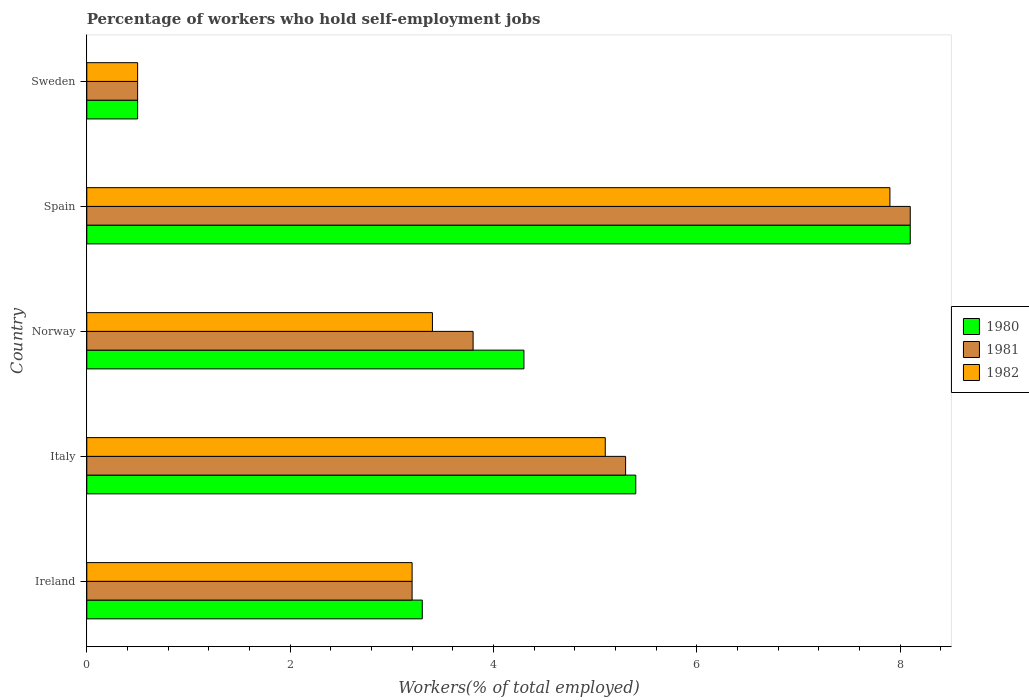How many different coloured bars are there?
Offer a very short reply. 3. How many groups of bars are there?
Provide a succinct answer. 5. Are the number of bars per tick equal to the number of legend labels?
Offer a very short reply. Yes. What is the label of the 5th group of bars from the top?
Offer a very short reply. Ireland. What is the percentage of self-employed workers in 1981 in Norway?
Make the answer very short. 3.8. Across all countries, what is the maximum percentage of self-employed workers in 1982?
Your answer should be compact. 7.9. Across all countries, what is the minimum percentage of self-employed workers in 1981?
Make the answer very short. 0.5. In which country was the percentage of self-employed workers in 1980 minimum?
Provide a succinct answer. Sweden. What is the total percentage of self-employed workers in 1982 in the graph?
Your answer should be very brief. 20.1. What is the difference between the percentage of self-employed workers in 1980 in Norway and that in Sweden?
Make the answer very short. 3.8. What is the difference between the percentage of self-employed workers in 1981 in Italy and the percentage of self-employed workers in 1982 in Spain?
Offer a terse response. -2.6. What is the average percentage of self-employed workers in 1982 per country?
Make the answer very short. 4.02. What is the difference between the percentage of self-employed workers in 1980 and percentage of self-employed workers in 1982 in Italy?
Provide a short and direct response. 0.3. What is the ratio of the percentage of self-employed workers in 1980 in Norway to that in Spain?
Give a very brief answer. 0.53. Is the percentage of self-employed workers in 1981 in Ireland less than that in Norway?
Keep it short and to the point. Yes. Is the difference between the percentage of self-employed workers in 1980 in Ireland and Sweden greater than the difference between the percentage of self-employed workers in 1982 in Ireland and Sweden?
Ensure brevity in your answer.  Yes. What is the difference between the highest and the second highest percentage of self-employed workers in 1981?
Keep it short and to the point. 2.8. What is the difference between the highest and the lowest percentage of self-employed workers in 1981?
Keep it short and to the point. 7.6. In how many countries, is the percentage of self-employed workers in 1982 greater than the average percentage of self-employed workers in 1982 taken over all countries?
Keep it short and to the point. 2. What does the 3rd bar from the top in Sweden represents?
Keep it short and to the point. 1980. How many countries are there in the graph?
Make the answer very short. 5. Are the values on the major ticks of X-axis written in scientific E-notation?
Offer a very short reply. No. Where does the legend appear in the graph?
Your response must be concise. Center right. How many legend labels are there?
Ensure brevity in your answer.  3. What is the title of the graph?
Make the answer very short. Percentage of workers who hold self-employment jobs. Does "1987" appear as one of the legend labels in the graph?
Provide a short and direct response. No. What is the label or title of the X-axis?
Offer a terse response. Workers(% of total employed). What is the label or title of the Y-axis?
Keep it short and to the point. Country. What is the Workers(% of total employed) of 1980 in Ireland?
Keep it short and to the point. 3.3. What is the Workers(% of total employed) in 1981 in Ireland?
Your response must be concise. 3.2. What is the Workers(% of total employed) of 1982 in Ireland?
Your answer should be compact. 3.2. What is the Workers(% of total employed) in 1980 in Italy?
Offer a very short reply. 5.4. What is the Workers(% of total employed) of 1981 in Italy?
Make the answer very short. 5.3. What is the Workers(% of total employed) of 1982 in Italy?
Provide a succinct answer. 5.1. What is the Workers(% of total employed) of 1980 in Norway?
Your response must be concise. 4.3. What is the Workers(% of total employed) of 1981 in Norway?
Keep it short and to the point. 3.8. What is the Workers(% of total employed) in 1982 in Norway?
Your response must be concise. 3.4. What is the Workers(% of total employed) of 1980 in Spain?
Ensure brevity in your answer.  8.1. What is the Workers(% of total employed) in 1981 in Spain?
Keep it short and to the point. 8.1. What is the Workers(% of total employed) in 1982 in Spain?
Give a very brief answer. 7.9. What is the Workers(% of total employed) of 1982 in Sweden?
Provide a short and direct response. 0.5. Across all countries, what is the maximum Workers(% of total employed) in 1980?
Your answer should be very brief. 8.1. Across all countries, what is the maximum Workers(% of total employed) of 1981?
Give a very brief answer. 8.1. Across all countries, what is the maximum Workers(% of total employed) in 1982?
Give a very brief answer. 7.9. Across all countries, what is the minimum Workers(% of total employed) of 1981?
Your answer should be very brief. 0.5. What is the total Workers(% of total employed) in 1980 in the graph?
Ensure brevity in your answer.  21.6. What is the total Workers(% of total employed) in 1981 in the graph?
Give a very brief answer. 20.9. What is the total Workers(% of total employed) in 1982 in the graph?
Your answer should be compact. 20.1. What is the difference between the Workers(% of total employed) of 1980 in Ireland and that in Italy?
Your answer should be very brief. -2.1. What is the difference between the Workers(% of total employed) in 1981 in Ireland and that in Italy?
Your answer should be very brief. -2.1. What is the difference between the Workers(% of total employed) of 1982 in Ireland and that in Italy?
Provide a short and direct response. -1.9. What is the difference between the Workers(% of total employed) in 1980 in Ireland and that in Norway?
Ensure brevity in your answer.  -1. What is the difference between the Workers(% of total employed) of 1981 in Ireland and that in Norway?
Give a very brief answer. -0.6. What is the difference between the Workers(% of total employed) of 1980 in Ireland and that in Spain?
Make the answer very short. -4.8. What is the difference between the Workers(% of total employed) of 1981 in Ireland and that in Spain?
Ensure brevity in your answer.  -4.9. What is the difference between the Workers(% of total employed) in 1980 in Ireland and that in Sweden?
Provide a short and direct response. 2.8. What is the difference between the Workers(% of total employed) in 1981 in Ireland and that in Sweden?
Provide a short and direct response. 2.7. What is the difference between the Workers(% of total employed) of 1980 in Italy and that in Norway?
Offer a very short reply. 1.1. What is the difference between the Workers(% of total employed) in 1981 in Italy and that in Norway?
Your response must be concise. 1.5. What is the difference between the Workers(% of total employed) in 1980 in Italy and that in Spain?
Offer a very short reply. -2.7. What is the difference between the Workers(% of total employed) of 1981 in Italy and that in Spain?
Give a very brief answer. -2.8. What is the difference between the Workers(% of total employed) in 1982 in Italy and that in Spain?
Your answer should be very brief. -2.8. What is the difference between the Workers(% of total employed) in 1981 in Italy and that in Sweden?
Offer a very short reply. 4.8. What is the difference between the Workers(% of total employed) of 1982 in Italy and that in Sweden?
Keep it short and to the point. 4.6. What is the difference between the Workers(% of total employed) of 1980 in Norway and that in Spain?
Give a very brief answer. -3.8. What is the difference between the Workers(% of total employed) in 1982 in Norway and that in Spain?
Offer a very short reply. -4.5. What is the difference between the Workers(% of total employed) of 1980 in Spain and that in Sweden?
Make the answer very short. 7.6. What is the difference between the Workers(% of total employed) in 1981 in Spain and that in Sweden?
Provide a succinct answer. 7.6. What is the difference between the Workers(% of total employed) in 1980 in Ireland and the Workers(% of total employed) in 1982 in Italy?
Your answer should be compact. -1.8. What is the difference between the Workers(% of total employed) of 1981 in Ireland and the Workers(% of total employed) of 1982 in Italy?
Your answer should be compact. -1.9. What is the difference between the Workers(% of total employed) of 1980 in Ireland and the Workers(% of total employed) of 1981 in Norway?
Offer a terse response. -0.5. What is the difference between the Workers(% of total employed) of 1980 in Ireland and the Workers(% of total employed) of 1982 in Norway?
Keep it short and to the point. -0.1. What is the difference between the Workers(% of total employed) of 1981 in Ireland and the Workers(% of total employed) of 1982 in Norway?
Make the answer very short. -0.2. What is the difference between the Workers(% of total employed) of 1980 in Ireland and the Workers(% of total employed) of 1981 in Spain?
Make the answer very short. -4.8. What is the difference between the Workers(% of total employed) of 1980 in Ireland and the Workers(% of total employed) of 1982 in Spain?
Keep it short and to the point. -4.6. What is the difference between the Workers(% of total employed) in 1980 in Italy and the Workers(% of total employed) in 1981 in Norway?
Keep it short and to the point. 1.6. What is the difference between the Workers(% of total employed) of 1981 in Italy and the Workers(% of total employed) of 1982 in Norway?
Ensure brevity in your answer.  1.9. What is the difference between the Workers(% of total employed) of 1980 in Italy and the Workers(% of total employed) of 1982 in Spain?
Provide a succinct answer. -2.5. What is the difference between the Workers(% of total employed) in 1980 in Italy and the Workers(% of total employed) in 1981 in Sweden?
Ensure brevity in your answer.  4.9. What is the difference between the Workers(% of total employed) in 1980 in Norway and the Workers(% of total employed) in 1982 in Spain?
Your response must be concise. -3.6. What is the difference between the Workers(% of total employed) of 1980 in Norway and the Workers(% of total employed) of 1981 in Sweden?
Provide a succinct answer. 3.8. What is the difference between the Workers(% of total employed) in 1981 in Norway and the Workers(% of total employed) in 1982 in Sweden?
Your answer should be very brief. 3.3. What is the difference between the Workers(% of total employed) of 1981 in Spain and the Workers(% of total employed) of 1982 in Sweden?
Your response must be concise. 7.6. What is the average Workers(% of total employed) in 1980 per country?
Keep it short and to the point. 4.32. What is the average Workers(% of total employed) of 1981 per country?
Give a very brief answer. 4.18. What is the average Workers(% of total employed) of 1982 per country?
Provide a succinct answer. 4.02. What is the difference between the Workers(% of total employed) in 1980 and Workers(% of total employed) in 1982 in Ireland?
Your response must be concise. 0.1. What is the difference between the Workers(% of total employed) in 1981 and Workers(% of total employed) in 1982 in Norway?
Your answer should be compact. 0.4. What is the difference between the Workers(% of total employed) of 1980 and Workers(% of total employed) of 1981 in Spain?
Give a very brief answer. 0. What is the difference between the Workers(% of total employed) of 1980 and Workers(% of total employed) of 1982 in Spain?
Give a very brief answer. 0.2. What is the difference between the Workers(% of total employed) in 1981 and Workers(% of total employed) in 1982 in Spain?
Keep it short and to the point. 0.2. What is the difference between the Workers(% of total employed) in 1980 and Workers(% of total employed) in 1982 in Sweden?
Provide a succinct answer. 0. What is the difference between the Workers(% of total employed) of 1981 and Workers(% of total employed) of 1982 in Sweden?
Make the answer very short. 0. What is the ratio of the Workers(% of total employed) in 1980 in Ireland to that in Italy?
Your answer should be compact. 0.61. What is the ratio of the Workers(% of total employed) in 1981 in Ireland to that in Italy?
Ensure brevity in your answer.  0.6. What is the ratio of the Workers(% of total employed) in 1982 in Ireland to that in Italy?
Provide a short and direct response. 0.63. What is the ratio of the Workers(% of total employed) of 1980 in Ireland to that in Norway?
Offer a very short reply. 0.77. What is the ratio of the Workers(% of total employed) in 1981 in Ireland to that in Norway?
Ensure brevity in your answer.  0.84. What is the ratio of the Workers(% of total employed) of 1980 in Ireland to that in Spain?
Provide a short and direct response. 0.41. What is the ratio of the Workers(% of total employed) in 1981 in Ireland to that in Spain?
Make the answer very short. 0.4. What is the ratio of the Workers(% of total employed) of 1982 in Ireland to that in Spain?
Your answer should be very brief. 0.41. What is the ratio of the Workers(% of total employed) of 1980 in Ireland to that in Sweden?
Ensure brevity in your answer.  6.6. What is the ratio of the Workers(% of total employed) in 1981 in Ireland to that in Sweden?
Your response must be concise. 6.4. What is the ratio of the Workers(% of total employed) of 1982 in Ireland to that in Sweden?
Your answer should be very brief. 6.4. What is the ratio of the Workers(% of total employed) in 1980 in Italy to that in Norway?
Give a very brief answer. 1.26. What is the ratio of the Workers(% of total employed) of 1981 in Italy to that in Norway?
Make the answer very short. 1.39. What is the ratio of the Workers(% of total employed) of 1981 in Italy to that in Spain?
Keep it short and to the point. 0.65. What is the ratio of the Workers(% of total employed) in 1982 in Italy to that in Spain?
Offer a very short reply. 0.65. What is the ratio of the Workers(% of total employed) of 1981 in Italy to that in Sweden?
Offer a very short reply. 10.6. What is the ratio of the Workers(% of total employed) in 1982 in Italy to that in Sweden?
Offer a very short reply. 10.2. What is the ratio of the Workers(% of total employed) in 1980 in Norway to that in Spain?
Your answer should be very brief. 0.53. What is the ratio of the Workers(% of total employed) of 1981 in Norway to that in Spain?
Make the answer very short. 0.47. What is the ratio of the Workers(% of total employed) in 1982 in Norway to that in Spain?
Your response must be concise. 0.43. What is the ratio of the Workers(% of total employed) in 1980 in Norway to that in Sweden?
Offer a terse response. 8.6. What is the ratio of the Workers(% of total employed) of 1980 in Spain to that in Sweden?
Provide a short and direct response. 16.2. What is the difference between the highest and the second highest Workers(% of total employed) of 1980?
Provide a short and direct response. 2.7. What is the difference between the highest and the second highest Workers(% of total employed) in 1982?
Make the answer very short. 2.8. What is the difference between the highest and the lowest Workers(% of total employed) in 1981?
Your response must be concise. 7.6. What is the difference between the highest and the lowest Workers(% of total employed) in 1982?
Provide a short and direct response. 7.4. 